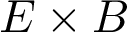Convert formula to latex. <formula><loc_0><loc_0><loc_500><loc_500>E \times B</formula> 